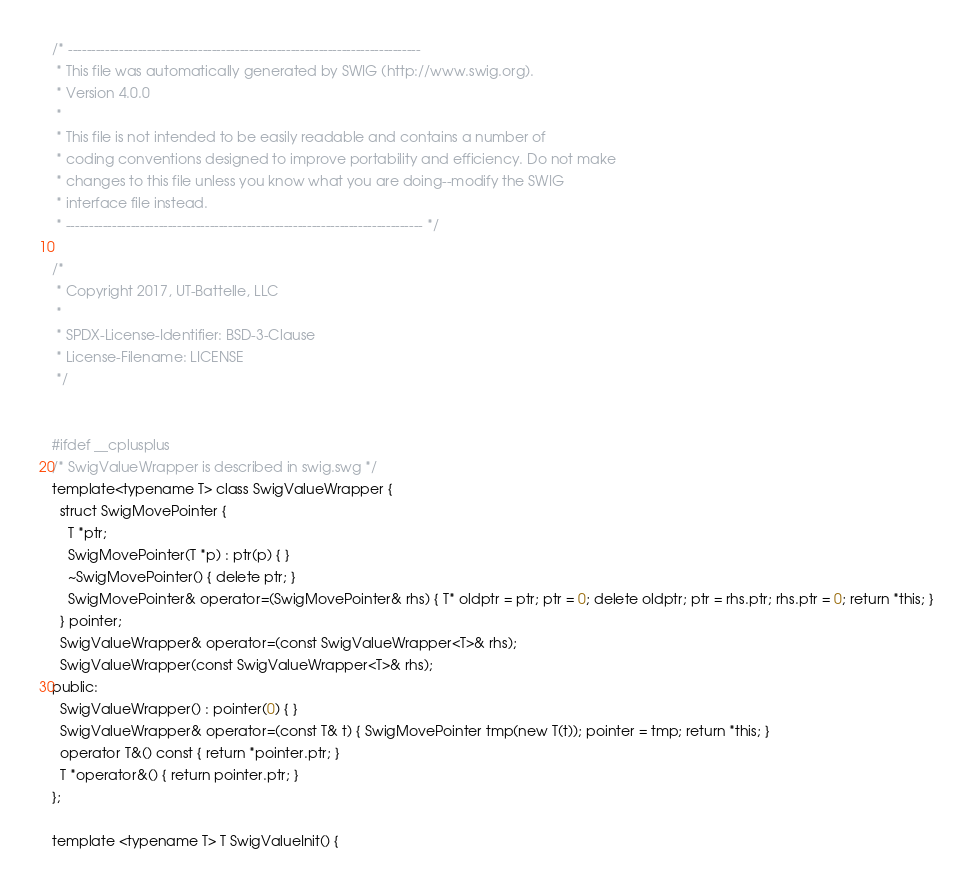Convert code to text. <code><loc_0><loc_0><loc_500><loc_500><_C++_>/* ----------------------------------------------------------------------------
 * This file was automatically generated by SWIG (http://www.swig.org).
 * Version 4.0.0
 *
 * This file is not intended to be easily readable and contains a number of
 * coding conventions designed to improve portability and efficiency. Do not make
 * changes to this file unless you know what you are doing--modify the SWIG
 * interface file instead.
 * ----------------------------------------------------------------------------- */

/*
 * Copyright 2017, UT-Battelle, LLC
 *
 * SPDX-License-Identifier: BSD-3-Clause
 * License-Filename: LICENSE
 */


#ifdef __cplusplus
/* SwigValueWrapper is described in swig.swg */
template<typename T> class SwigValueWrapper {
  struct SwigMovePointer {
    T *ptr;
    SwigMovePointer(T *p) : ptr(p) { }
    ~SwigMovePointer() { delete ptr; }
    SwigMovePointer& operator=(SwigMovePointer& rhs) { T* oldptr = ptr; ptr = 0; delete oldptr; ptr = rhs.ptr; rhs.ptr = 0; return *this; }
  } pointer;
  SwigValueWrapper& operator=(const SwigValueWrapper<T>& rhs);
  SwigValueWrapper(const SwigValueWrapper<T>& rhs);
public:
  SwigValueWrapper() : pointer(0) { }
  SwigValueWrapper& operator=(const T& t) { SwigMovePointer tmp(new T(t)); pointer = tmp; return *this; }
  operator T&() const { return *pointer.ptr; }
  T *operator&() { return pointer.ptr; }
};

template <typename T> T SwigValueInit() {</code> 